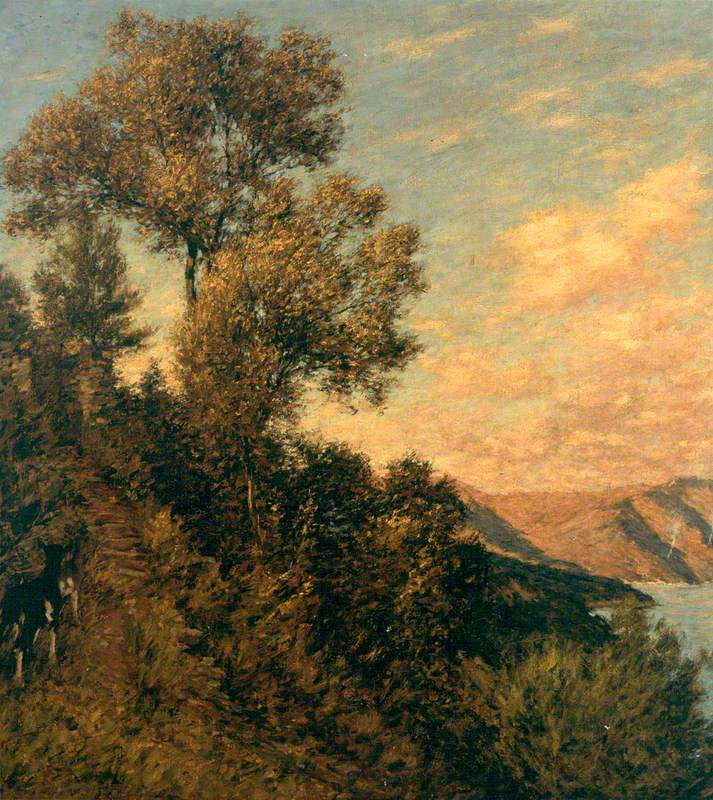What do the colors in the sky suggest about the time and mood of the scene? The hues of orange and gold melting into soft blues suggest the painting likely depicts either dawn or dusk. These times of day are known for their magical and transient light, which often evokes feelings of peace and reflection. The artist's use of warm tones against a cooler backdrop creates a harmonious and somewhat introspective mood, inviting the viewer to pause and reflect on the day's transition. 